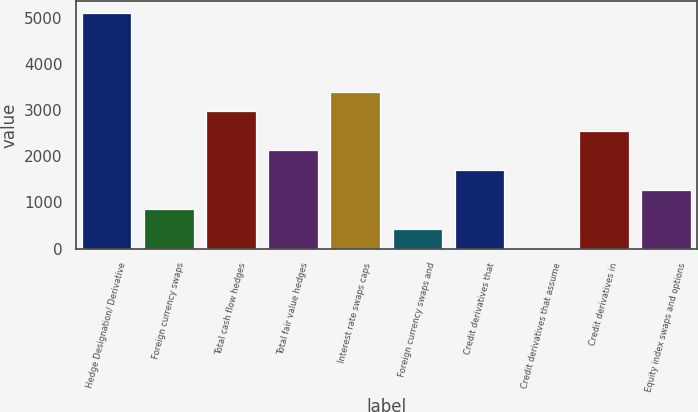Convert chart. <chart><loc_0><loc_0><loc_500><loc_500><bar_chart><fcel>Hedge Designation/ Derivative<fcel>Foreign currency swaps<fcel>Total cash flow hedges<fcel>Total fair value hedges<fcel>Interest rate swaps caps<fcel>Foreign currency swaps and<fcel>Credit derivatives that<fcel>Credit derivatives that assume<fcel>Credit derivatives in<fcel>Equity index swaps and options<nl><fcel>5111.6<fcel>853.6<fcel>2982.6<fcel>2131<fcel>3408.4<fcel>427.8<fcel>1705.2<fcel>2<fcel>2556.8<fcel>1279.4<nl></chart> 